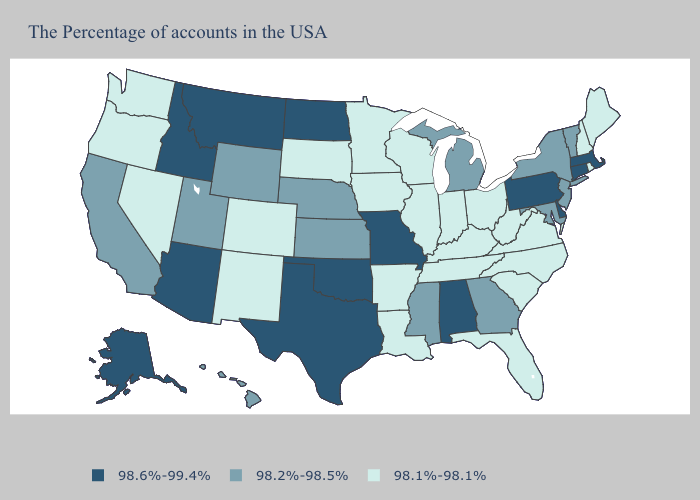What is the highest value in the USA?
Quick response, please. 98.6%-99.4%. Does New Jersey have the lowest value in the Northeast?
Keep it brief. No. Among the states that border Michigan , which have the lowest value?
Write a very short answer. Ohio, Indiana, Wisconsin. Among the states that border Washington , which have the highest value?
Give a very brief answer. Idaho. What is the value of Indiana?
Answer briefly. 98.1%-98.1%. Does Virginia have a higher value than Connecticut?
Short answer required. No. What is the value of Kansas?
Be succinct. 98.2%-98.5%. Among the states that border Vermont , which have the lowest value?
Give a very brief answer. New Hampshire. Name the states that have a value in the range 98.1%-98.1%?
Answer briefly. Maine, Rhode Island, New Hampshire, Virginia, North Carolina, South Carolina, West Virginia, Ohio, Florida, Kentucky, Indiana, Tennessee, Wisconsin, Illinois, Louisiana, Arkansas, Minnesota, Iowa, South Dakota, Colorado, New Mexico, Nevada, Washington, Oregon. What is the value of West Virginia?
Answer briefly. 98.1%-98.1%. Name the states that have a value in the range 98.6%-99.4%?
Write a very short answer. Massachusetts, Connecticut, Delaware, Pennsylvania, Alabama, Missouri, Oklahoma, Texas, North Dakota, Montana, Arizona, Idaho, Alaska. How many symbols are there in the legend?
Keep it brief. 3. How many symbols are there in the legend?
Be succinct. 3. Name the states that have a value in the range 98.1%-98.1%?
Be succinct. Maine, Rhode Island, New Hampshire, Virginia, North Carolina, South Carolina, West Virginia, Ohio, Florida, Kentucky, Indiana, Tennessee, Wisconsin, Illinois, Louisiana, Arkansas, Minnesota, Iowa, South Dakota, Colorado, New Mexico, Nevada, Washington, Oregon. Which states have the highest value in the USA?
Concise answer only. Massachusetts, Connecticut, Delaware, Pennsylvania, Alabama, Missouri, Oklahoma, Texas, North Dakota, Montana, Arizona, Idaho, Alaska. 